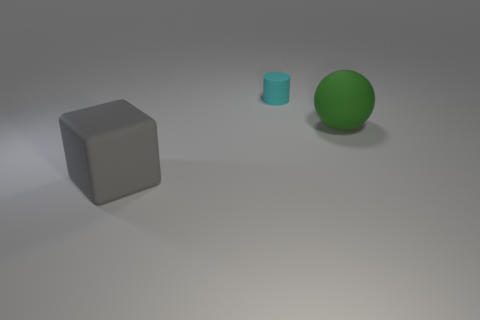Add 1 cyan rubber cylinders. How many objects exist? 4 Subtract all tiny purple rubber cylinders. Subtract all large green matte things. How many objects are left? 2 Add 3 tiny cyan things. How many tiny cyan things are left? 4 Add 1 small blue shiny objects. How many small blue shiny objects exist? 1 Subtract 1 green balls. How many objects are left? 2 Subtract all blocks. How many objects are left? 2 Subtract 1 balls. How many balls are left? 0 Subtract all gray cylinders. Subtract all green spheres. How many cylinders are left? 1 